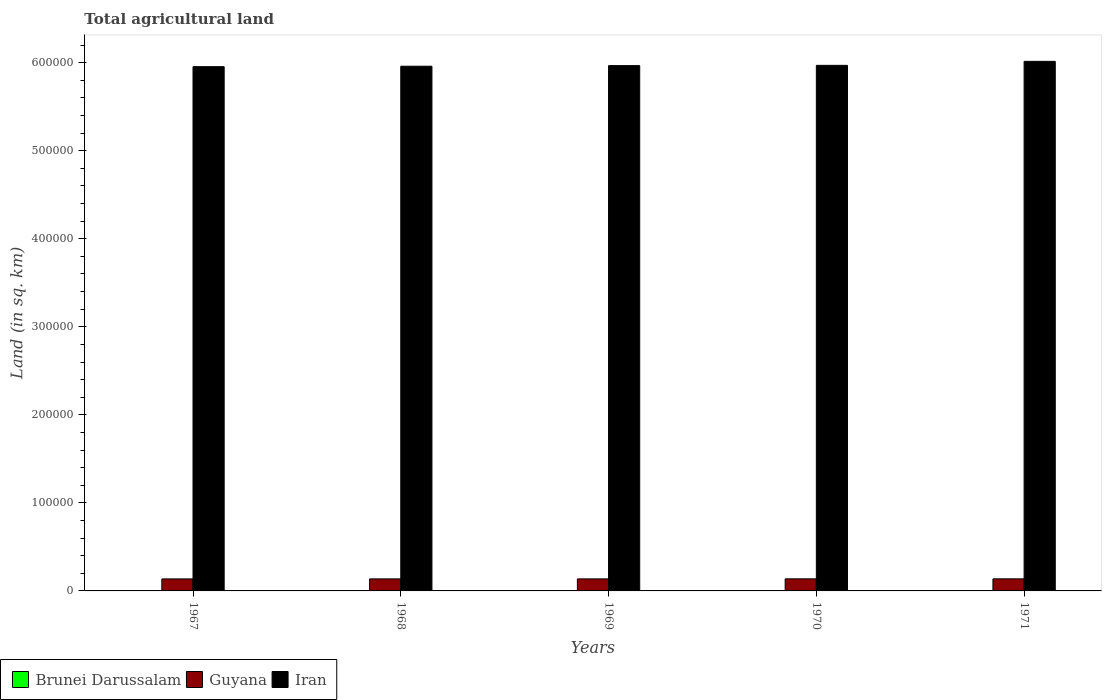How many different coloured bars are there?
Provide a short and direct response. 3. How many groups of bars are there?
Your response must be concise. 5. Are the number of bars on each tick of the X-axis equal?
Your response must be concise. Yes. How many bars are there on the 2nd tick from the left?
Your answer should be compact. 3. How many bars are there on the 4th tick from the right?
Provide a short and direct response. 3. What is the label of the 3rd group of bars from the left?
Offer a terse response. 1969. In how many cases, is the number of bars for a given year not equal to the number of legend labels?
Your answer should be very brief. 0. What is the total agricultural land in Iran in 1971?
Offer a terse response. 6.02e+05. Across all years, what is the maximum total agricultural land in Brunei Darussalam?
Offer a terse response. 240. Across all years, what is the minimum total agricultural land in Brunei Darussalam?
Make the answer very short. 190. In which year was the total agricultural land in Guyana maximum?
Provide a short and direct response. 1970. In which year was the total agricultural land in Guyana minimum?
Give a very brief answer. 1967. What is the total total agricultural land in Guyana in the graph?
Keep it short and to the point. 6.84e+04. What is the difference between the total agricultural land in Iran in 1969 and that in 1970?
Offer a very short reply. -300. What is the difference between the total agricultural land in Iran in 1968 and the total agricultural land in Brunei Darussalam in 1970?
Your answer should be very brief. 5.96e+05. What is the average total agricultural land in Iran per year?
Offer a terse response. 5.97e+05. In the year 1971, what is the difference between the total agricultural land in Brunei Darussalam and total agricultural land in Iran?
Provide a succinct answer. -6.01e+05. What is the ratio of the total agricultural land in Iran in 1968 to that in 1970?
Give a very brief answer. 1. What is the difference between the highest and the lowest total agricultural land in Guyana?
Offer a terse response. 70. In how many years, is the total agricultural land in Brunei Darussalam greater than the average total agricultural land in Brunei Darussalam taken over all years?
Provide a succinct answer. 4. Is the sum of the total agricultural land in Iran in 1967 and 1970 greater than the maximum total agricultural land in Guyana across all years?
Your response must be concise. Yes. What does the 3rd bar from the left in 1971 represents?
Keep it short and to the point. Iran. What does the 2nd bar from the right in 1971 represents?
Ensure brevity in your answer.  Guyana. Is it the case that in every year, the sum of the total agricultural land in Guyana and total agricultural land in Iran is greater than the total agricultural land in Brunei Darussalam?
Ensure brevity in your answer.  Yes. How many bars are there?
Make the answer very short. 15. How many years are there in the graph?
Provide a short and direct response. 5. What is the difference between two consecutive major ticks on the Y-axis?
Make the answer very short. 1.00e+05. Are the values on the major ticks of Y-axis written in scientific E-notation?
Ensure brevity in your answer.  No. Where does the legend appear in the graph?
Your answer should be compact. Bottom left. How many legend labels are there?
Offer a terse response. 3. What is the title of the graph?
Give a very brief answer. Total agricultural land. Does "Uzbekistan" appear as one of the legend labels in the graph?
Offer a very short reply. No. What is the label or title of the Y-axis?
Offer a terse response. Land (in sq. km). What is the Land (in sq. km) of Brunei Darussalam in 1967?
Give a very brief answer. 230. What is the Land (in sq. km) of Guyana in 1967?
Ensure brevity in your answer.  1.36e+04. What is the Land (in sq. km) of Iran in 1967?
Make the answer very short. 5.96e+05. What is the Land (in sq. km) of Brunei Darussalam in 1968?
Keep it short and to the point. 240. What is the Land (in sq. km) of Guyana in 1968?
Your response must be concise. 1.37e+04. What is the Land (in sq. km) in Iran in 1968?
Your answer should be compact. 5.96e+05. What is the Land (in sq. km) in Brunei Darussalam in 1969?
Offer a very short reply. 240. What is the Land (in sq. km) in Guyana in 1969?
Ensure brevity in your answer.  1.37e+04. What is the Land (in sq. km) in Iran in 1969?
Offer a very short reply. 5.97e+05. What is the Land (in sq. km) in Brunei Darussalam in 1970?
Your response must be concise. 240. What is the Land (in sq. km) in Guyana in 1970?
Offer a terse response. 1.37e+04. What is the Land (in sq. km) in Iran in 1970?
Offer a very short reply. 5.97e+05. What is the Land (in sq. km) in Brunei Darussalam in 1971?
Your answer should be compact. 190. What is the Land (in sq. km) of Guyana in 1971?
Your answer should be very brief. 1.37e+04. What is the Land (in sq. km) in Iran in 1971?
Give a very brief answer. 6.02e+05. Across all years, what is the maximum Land (in sq. km) in Brunei Darussalam?
Offer a terse response. 240. Across all years, what is the maximum Land (in sq. km) of Guyana?
Offer a very short reply. 1.37e+04. Across all years, what is the maximum Land (in sq. km) of Iran?
Make the answer very short. 6.02e+05. Across all years, what is the minimum Land (in sq. km) of Brunei Darussalam?
Keep it short and to the point. 190. Across all years, what is the minimum Land (in sq. km) of Guyana?
Keep it short and to the point. 1.36e+04. Across all years, what is the minimum Land (in sq. km) in Iran?
Offer a very short reply. 5.96e+05. What is the total Land (in sq. km) of Brunei Darussalam in the graph?
Offer a very short reply. 1140. What is the total Land (in sq. km) in Guyana in the graph?
Your answer should be compact. 6.84e+04. What is the total Land (in sq. km) of Iran in the graph?
Ensure brevity in your answer.  2.99e+06. What is the difference between the Land (in sq. km) of Iran in 1967 and that in 1968?
Make the answer very short. -500. What is the difference between the Land (in sq. km) in Iran in 1967 and that in 1969?
Offer a terse response. -1200. What is the difference between the Land (in sq. km) in Guyana in 1967 and that in 1970?
Offer a terse response. -70. What is the difference between the Land (in sq. km) in Iran in 1967 and that in 1970?
Give a very brief answer. -1500. What is the difference between the Land (in sq. km) of Brunei Darussalam in 1967 and that in 1971?
Offer a very short reply. 40. What is the difference between the Land (in sq. km) in Guyana in 1967 and that in 1971?
Make the answer very short. -70. What is the difference between the Land (in sq. km) of Iran in 1967 and that in 1971?
Your answer should be very brief. -6040. What is the difference between the Land (in sq. km) in Iran in 1968 and that in 1969?
Make the answer very short. -700. What is the difference between the Land (in sq. km) of Brunei Darussalam in 1968 and that in 1970?
Keep it short and to the point. 0. What is the difference between the Land (in sq. km) in Guyana in 1968 and that in 1970?
Ensure brevity in your answer.  -50. What is the difference between the Land (in sq. km) in Iran in 1968 and that in 1970?
Your response must be concise. -1000. What is the difference between the Land (in sq. km) in Iran in 1968 and that in 1971?
Your response must be concise. -5540. What is the difference between the Land (in sq. km) in Brunei Darussalam in 1969 and that in 1970?
Make the answer very short. 0. What is the difference between the Land (in sq. km) in Guyana in 1969 and that in 1970?
Give a very brief answer. -50. What is the difference between the Land (in sq. km) of Iran in 1969 and that in 1970?
Your answer should be very brief. -300. What is the difference between the Land (in sq. km) of Brunei Darussalam in 1969 and that in 1971?
Your answer should be very brief. 50. What is the difference between the Land (in sq. km) in Guyana in 1969 and that in 1971?
Offer a very short reply. -50. What is the difference between the Land (in sq. km) in Iran in 1969 and that in 1971?
Give a very brief answer. -4840. What is the difference between the Land (in sq. km) of Brunei Darussalam in 1970 and that in 1971?
Ensure brevity in your answer.  50. What is the difference between the Land (in sq. km) in Guyana in 1970 and that in 1971?
Ensure brevity in your answer.  0. What is the difference between the Land (in sq. km) of Iran in 1970 and that in 1971?
Provide a succinct answer. -4540. What is the difference between the Land (in sq. km) of Brunei Darussalam in 1967 and the Land (in sq. km) of Guyana in 1968?
Ensure brevity in your answer.  -1.34e+04. What is the difference between the Land (in sq. km) in Brunei Darussalam in 1967 and the Land (in sq. km) in Iran in 1968?
Make the answer very short. -5.96e+05. What is the difference between the Land (in sq. km) in Guyana in 1967 and the Land (in sq. km) in Iran in 1968?
Your answer should be very brief. -5.82e+05. What is the difference between the Land (in sq. km) in Brunei Darussalam in 1967 and the Land (in sq. km) in Guyana in 1969?
Offer a terse response. -1.34e+04. What is the difference between the Land (in sq. km) of Brunei Darussalam in 1967 and the Land (in sq. km) of Iran in 1969?
Your answer should be very brief. -5.96e+05. What is the difference between the Land (in sq. km) of Guyana in 1967 and the Land (in sq. km) of Iran in 1969?
Ensure brevity in your answer.  -5.83e+05. What is the difference between the Land (in sq. km) of Brunei Darussalam in 1967 and the Land (in sq. km) of Guyana in 1970?
Provide a succinct answer. -1.35e+04. What is the difference between the Land (in sq. km) of Brunei Darussalam in 1967 and the Land (in sq. km) of Iran in 1970?
Provide a short and direct response. -5.97e+05. What is the difference between the Land (in sq. km) in Guyana in 1967 and the Land (in sq. km) in Iran in 1970?
Your response must be concise. -5.83e+05. What is the difference between the Land (in sq. km) of Brunei Darussalam in 1967 and the Land (in sq. km) of Guyana in 1971?
Your answer should be compact. -1.35e+04. What is the difference between the Land (in sq. km) of Brunei Darussalam in 1967 and the Land (in sq. km) of Iran in 1971?
Your answer should be compact. -6.01e+05. What is the difference between the Land (in sq. km) in Guyana in 1967 and the Land (in sq. km) in Iran in 1971?
Keep it short and to the point. -5.88e+05. What is the difference between the Land (in sq. km) of Brunei Darussalam in 1968 and the Land (in sq. km) of Guyana in 1969?
Ensure brevity in your answer.  -1.34e+04. What is the difference between the Land (in sq. km) of Brunei Darussalam in 1968 and the Land (in sq. km) of Iran in 1969?
Your answer should be compact. -5.96e+05. What is the difference between the Land (in sq. km) of Guyana in 1968 and the Land (in sq. km) of Iran in 1969?
Your answer should be compact. -5.83e+05. What is the difference between the Land (in sq. km) in Brunei Darussalam in 1968 and the Land (in sq. km) in Guyana in 1970?
Offer a very short reply. -1.35e+04. What is the difference between the Land (in sq. km) in Brunei Darussalam in 1968 and the Land (in sq. km) in Iran in 1970?
Your answer should be compact. -5.97e+05. What is the difference between the Land (in sq. km) of Guyana in 1968 and the Land (in sq. km) of Iran in 1970?
Keep it short and to the point. -5.83e+05. What is the difference between the Land (in sq. km) in Brunei Darussalam in 1968 and the Land (in sq. km) in Guyana in 1971?
Keep it short and to the point. -1.35e+04. What is the difference between the Land (in sq. km) in Brunei Darussalam in 1968 and the Land (in sq. km) in Iran in 1971?
Make the answer very short. -6.01e+05. What is the difference between the Land (in sq. km) in Guyana in 1968 and the Land (in sq. km) in Iran in 1971?
Ensure brevity in your answer.  -5.88e+05. What is the difference between the Land (in sq. km) in Brunei Darussalam in 1969 and the Land (in sq. km) in Guyana in 1970?
Your answer should be compact. -1.35e+04. What is the difference between the Land (in sq. km) in Brunei Darussalam in 1969 and the Land (in sq. km) in Iran in 1970?
Your response must be concise. -5.97e+05. What is the difference between the Land (in sq. km) in Guyana in 1969 and the Land (in sq. km) in Iran in 1970?
Your response must be concise. -5.83e+05. What is the difference between the Land (in sq. km) in Brunei Darussalam in 1969 and the Land (in sq. km) in Guyana in 1971?
Offer a very short reply. -1.35e+04. What is the difference between the Land (in sq. km) in Brunei Darussalam in 1969 and the Land (in sq. km) in Iran in 1971?
Offer a very short reply. -6.01e+05. What is the difference between the Land (in sq. km) of Guyana in 1969 and the Land (in sq. km) of Iran in 1971?
Provide a succinct answer. -5.88e+05. What is the difference between the Land (in sq. km) in Brunei Darussalam in 1970 and the Land (in sq. km) in Guyana in 1971?
Keep it short and to the point. -1.35e+04. What is the difference between the Land (in sq. km) of Brunei Darussalam in 1970 and the Land (in sq. km) of Iran in 1971?
Give a very brief answer. -6.01e+05. What is the difference between the Land (in sq. km) of Guyana in 1970 and the Land (in sq. km) of Iran in 1971?
Your answer should be very brief. -5.88e+05. What is the average Land (in sq. km) in Brunei Darussalam per year?
Offer a terse response. 228. What is the average Land (in sq. km) in Guyana per year?
Your response must be concise. 1.37e+04. What is the average Land (in sq. km) in Iran per year?
Offer a very short reply. 5.97e+05. In the year 1967, what is the difference between the Land (in sq. km) in Brunei Darussalam and Land (in sq. km) in Guyana?
Give a very brief answer. -1.34e+04. In the year 1967, what is the difference between the Land (in sq. km) of Brunei Darussalam and Land (in sq. km) of Iran?
Provide a succinct answer. -5.95e+05. In the year 1967, what is the difference between the Land (in sq. km) in Guyana and Land (in sq. km) in Iran?
Your response must be concise. -5.82e+05. In the year 1968, what is the difference between the Land (in sq. km) in Brunei Darussalam and Land (in sq. km) in Guyana?
Offer a terse response. -1.34e+04. In the year 1968, what is the difference between the Land (in sq. km) of Brunei Darussalam and Land (in sq. km) of Iran?
Your answer should be compact. -5.96e+05. In the year 1968, what is the difference between the Land (in sq. km) of Guyana and Land (in sq. km) of Iran?
Give a very brief answer. -5.82e+05. In the year 1969, what is the difference between the Land (in sq. km) in Brunei Darussalam and Land (in sq. km) in Guyana?
Your answer should be compact. -1.34e+04. In the year 1969, what is the difference between the Land (in sq. km) of Brunei Darussalam and Land (in sq. km) of Iran?
Ensure brevity in your answer.  -5.96e+05. In the year 1969, what is the difference between the Land (in sq. km) of Guyana and Land (in sq. km) of Iran?
Make the answer very short. -5.83e+05. In the year 1970, what is the difference between the Land (in sq. km) of Brunei Darussalam and Land (in sq. km) of Guyana?
Ensure brevity in your answer.  -1.35e+04. In the year 1970, what is the difference between the Land (in sq. km) in Brunei Darussalam and Land (in sq. km) in Iran?
Give a very brief answer. -5.97e+05. In the year 1970, what is the difference between the Land (in sq. km) in Guyana and Land (in sq. km) in Iran?
Offer a terse response. -5.83e+05. In the year 1971, what is the difference between the Land (in sq. km) in Brunei Darussalam and Land (in sq. km) in Guyana?
Give a very brief answer. -1.35e+04. In the year 1971, what is the difference between the Land (in sq. km) in Brunei Darussalam and Land (in sq. km) in Iran?
Offer a terse response. -6.01e+05. In the year 1971, what is the difference between the Land (in sq. km) of Guyana and Land (in sq. km) of Iran?
Your answer should be compact. -5.88e+05. What is the ratio of the Land (in sq. km) of Guyana in 1967 to that in 1968?
Ensure brevity in your answer.  1. What is the ratio of the Land (in sq. km) of Brunei Darussalam in 1967 to that in 1970?
Your answer should be very brief. 0.96. What is the ratio of the Land (in sq. km) in Guyana in 1967 to that in 1970?
Provide a short and direct response. 0.99. What is the ratio of the Land (in sq. km) of Iran in 1967 to that in 1970?
Your answer should be very brief. 1. What is the ratio of the Land (in sq. km) of Brunei Darussalam in 1967 to that in 1971?
Provide a succinct answer. 1.21. What is the ratio of the Land (in sq. km) of Iran in 1967 to that in 1971?
Keep it short and to the point. 0.99. What is the ratio of the Land (in sq. km) in Guyana in 1968 to that in 1969?
Ensure brevity in your answer.  1. What is the ratio of the Land (in sq. km) in Brunei Darussalam in 1968 to that in 1970?
Ensure brevity in your answer.  1. What is the ratio of the Land (in sq. km) of Guyana in 1968 to that in 1970?
Make the answer very short. 1. What is the ratio of the Land (in sq. km) in Iran in 1968 to that in 1970?
Your answer should be compact. 1. What is the ratio of the Land (in sq. km) of Brunei Darussalam in 1968 to that in 1971?
Make the answer very short. 1.26. What is the ratio of the Land (in sq. km) of Guyana in 1968 to that in 1971?
Your answer should be very brief. 1. What is the ratio of the Land (in sq. km) in Brunei Darussalam in 1969 to that in 1970?
Make the answer very short. 1. What is the ratio of the Land (in sq. km) of Guyana in 1969 to that in 1970?
Keep it short and to the point. 1. What is the ratio of the Land (in sq. km) of Iran in 1969 to that in 1970?
Provide a short and direct response. 1. What is the ratio of the Land (in sq. km) in Brunei Darussalam in 1969 to that in 1971?
Offer a terse response. 1.26. What is the ratio of the Land (in sq. km) in Guyana in 1969 to that in 1971?
Make the answer very short. 1. What is the ratio of the Land (in sq. km) of Iran in 1969 to that in 1971?
Offer a terse response. 0.99. What is the ratio of the Land (in sq. km) in Brunei Darussalam in 1970 to that in 1971?
Provide a succinct answer. 1.26. What is the ratio of the Land (in sq. km) in Guyana in 1970 to that in 1971?
Make the answer very short. 1. What is the difference between the highest and the second highest Land (in sq. km) in Brunei Darussalam?
Ensure brevity in your answer.  0. What is the difference between the highest and the second highest Land (in sq. km) in Iran?
Offer a terse response. 4540. What is the difference between the highest and the lowest Land (in sq. km) in Guyana?
Your answer should be very brief. 70. What is the difference between the highest and the lowest Land (in sq. km) in Iran?
Keep it short and to the point. 6040. 